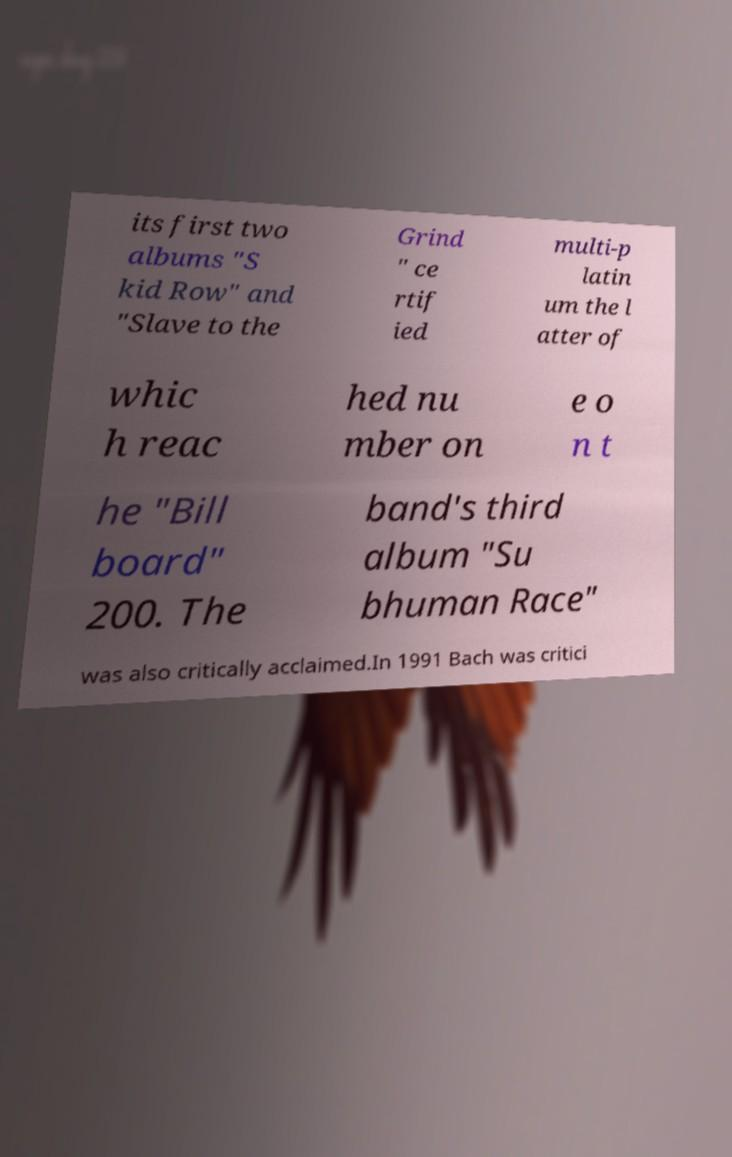I need the written content from this picture converted into text. Can you do that? its first two albums "S kid Row" and "Slave to the Grind " ce rtif ied multi-p latin um the l atter of whic h reac hed nu mber on e o n t he "Bill board" 200. The band's third album "Su bhuman Race" was also critically acclaimed.In 1991 Bach was critici 